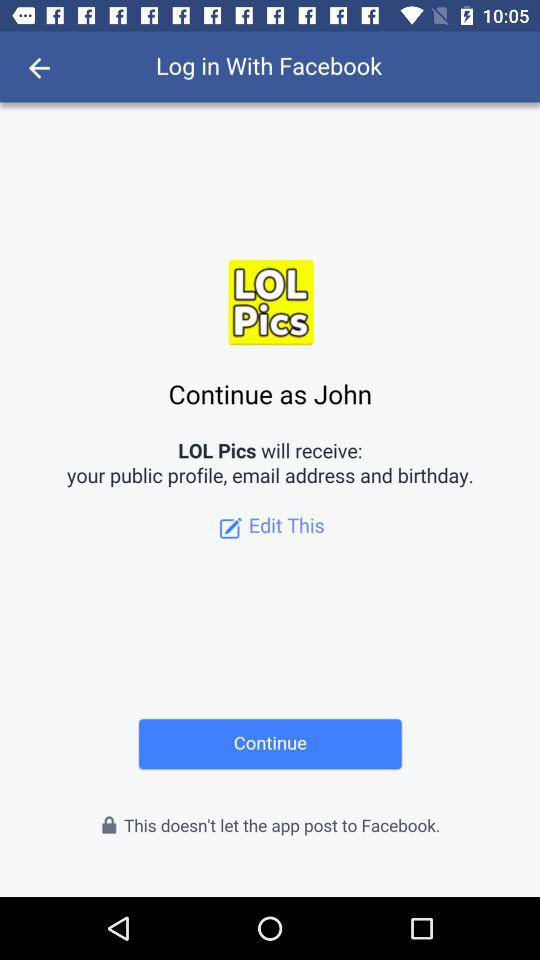What application is asking for permission? The application asking for permission is "LOL Pics". 